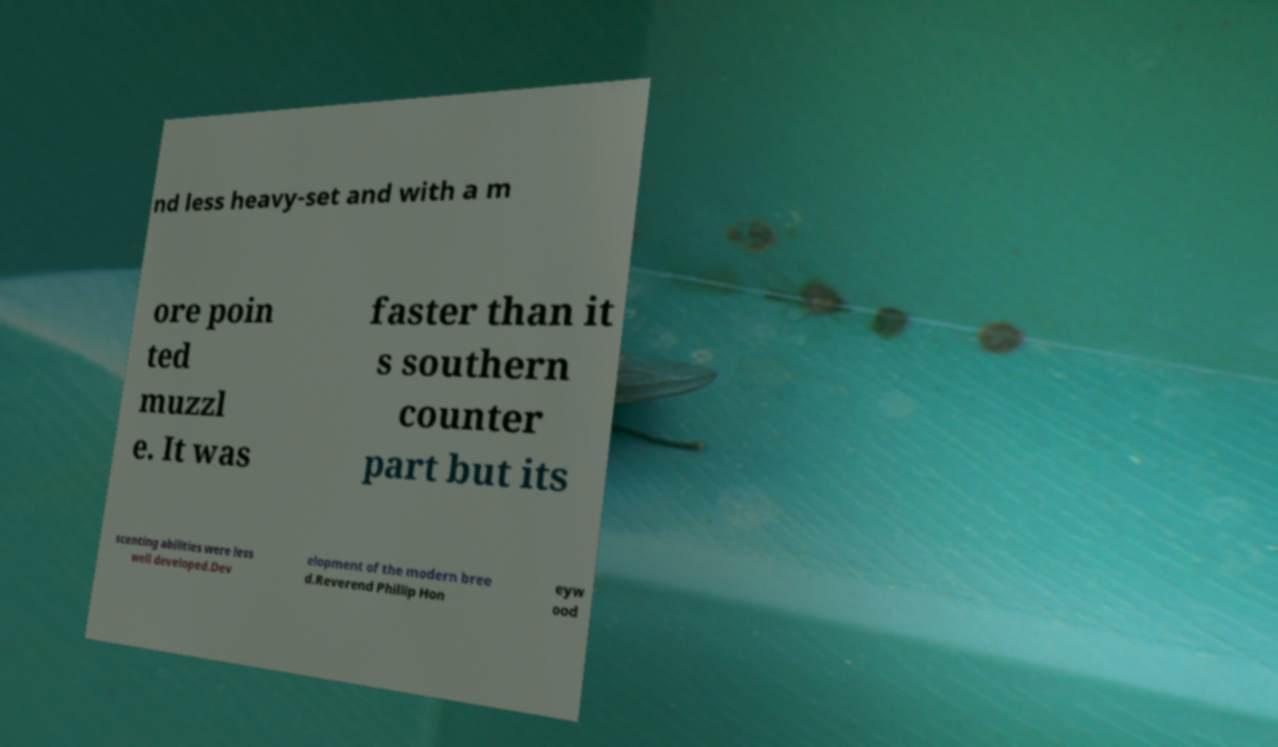Please read and relay the text visible in this image. What does it say? nd less heavy-set and with a m ore poin ted muzzl e. It was faster than it s southern counter part but its scenting abilities were less well developed.Dev elopment of the modern bree d.Reverend Phillip Hon eyw ood 